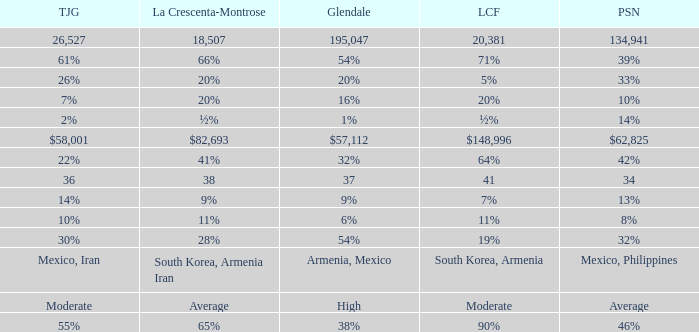If glendale's amount is $57,112, what is the corresponding figure for la crescenta-montrose? $82,693. 